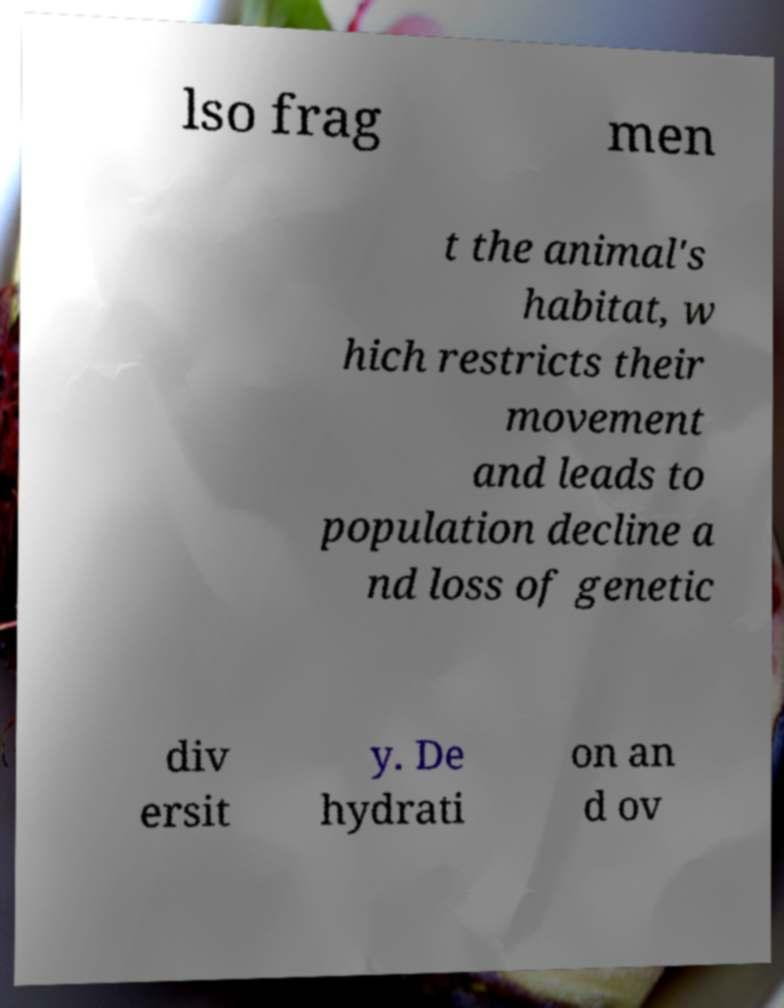Could you assist in decoding the text presented in this image and type it out clearly? lso frag men t the animal's habitat, w hich restricts their movement and leads to population decline a nd loss of genetic div ersit y. De hydrati on an d ov 